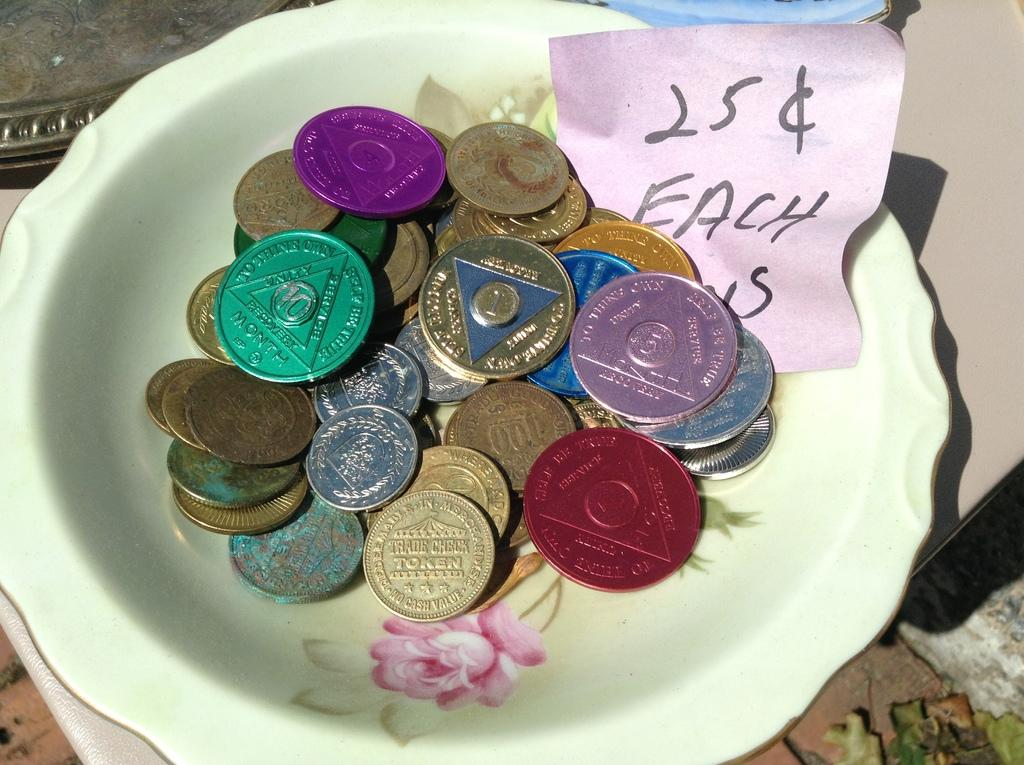Provide a one-sentence caption for the provided image. A bowl of tokens are priced at 25 cents each. 